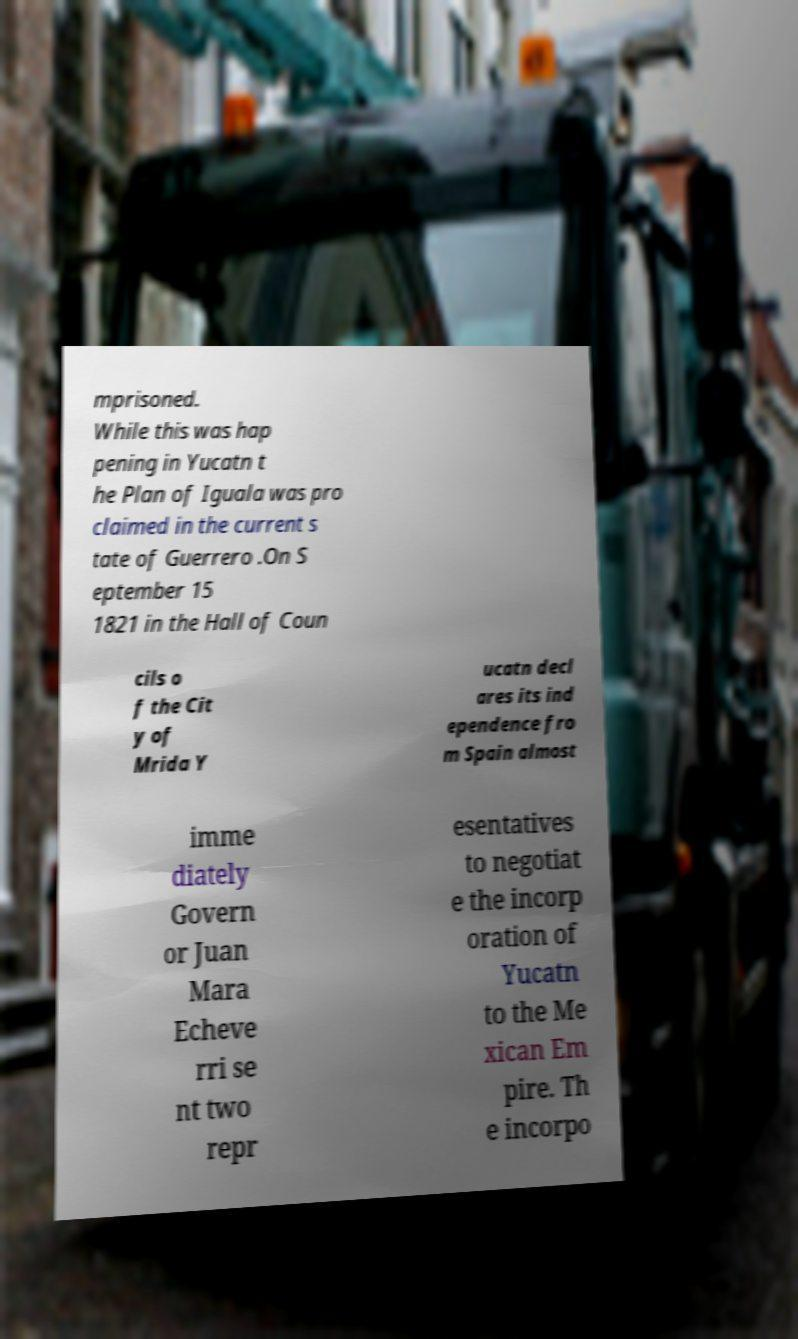Can you read and provide the text displayed in the image?This photo seems to have some interesting text. Can you extract and type it out for me? mprisoned. While this was hap pening in Yucatn t he Plan of Iguala was pro claimed in the current s tate of Guerrero .On S eptember 15 1821 in the Hall of Coun cils o f the Cit y of Mrida Y ucatn decl ares its ind ependence fro m Spain almost imme diately Govern or Juan Mara Echeve rri se nt two repr esentatives to negotiat e the incorp oration of Yucatn to the Me xican Em pire. Th e incorpo 